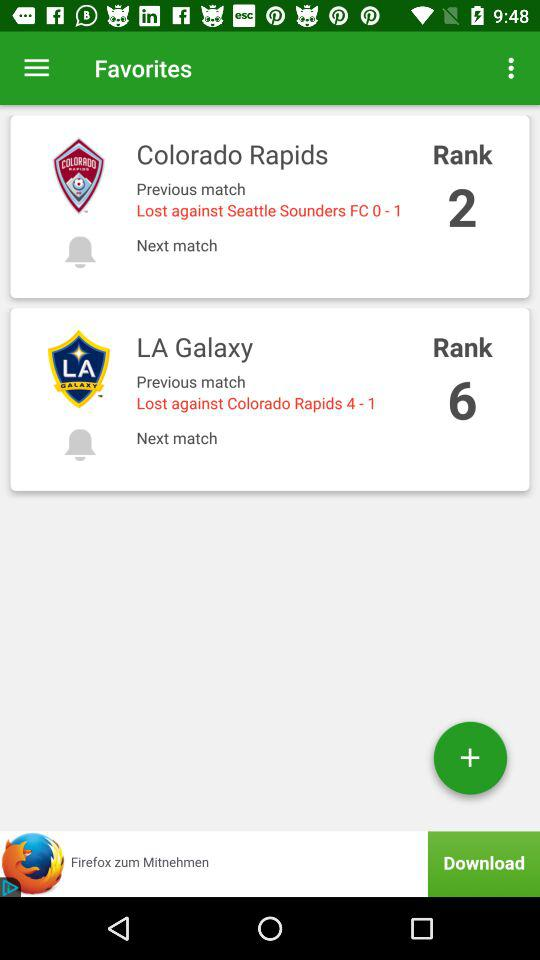Which team is ranked first?
When the provided information is insufficient, respond with <no answer>. <no answer> 